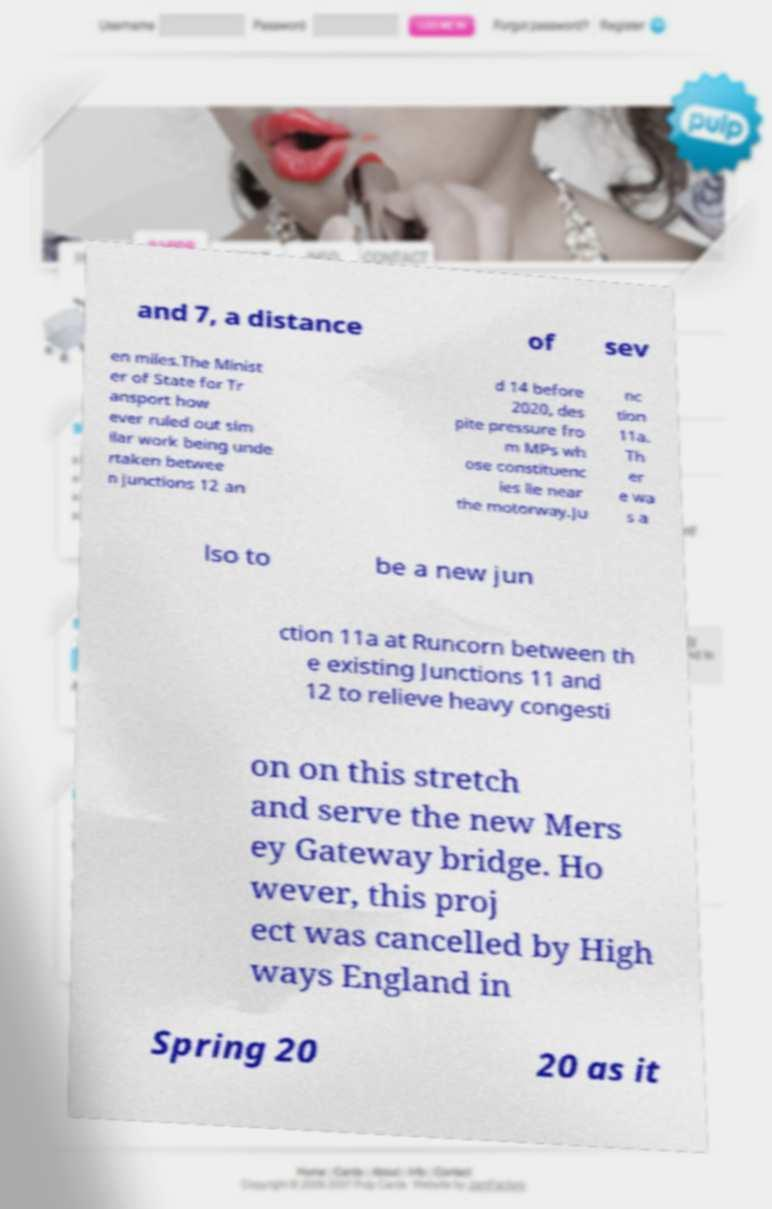Please identify and transcribe the text found in this image. and 7, a distance of sev en miles.The Minist er of State for Tr ansport how ever ruled out sim ilar work being unde rtaken betwee n junctions 12 an d 14 before 2020, des pite pressure fro m MPs wh ose constituenc ies lie near the motorway.Ju nc tion 11a. Th er e wa s a lso to be a new jun ction 11a at Runcorn between th e existing Junctions 11 and 12 to relieve heavy congesti on on this stretch and serve the new Mers ey Gateway bridge. Ho wever, this proj ect was cancelled by High ways England in Spring 20 20 as it 